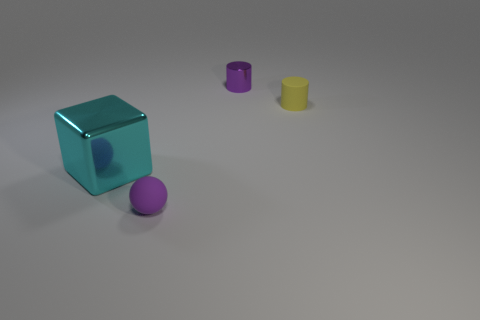Add 3 blocks. How many objects exist? 7 Subtract all balls. How many objects are left? 3 Add 2 large metal things. How many large metal things exist? 3 Subtract 0 green cubes. How many objects are left? 4 Subtract all yellow cylinders. Subtract all blue cubes. How many cylinders are left? 1 Subtract all purple balls. How many purple cylinders are left? 1 Subtract all small yellow rubber cylinders. Subtract all purple rubber balls. How many objects are left? 2 Add 2 purple matte objects. How many purple matte objects are left? 3 